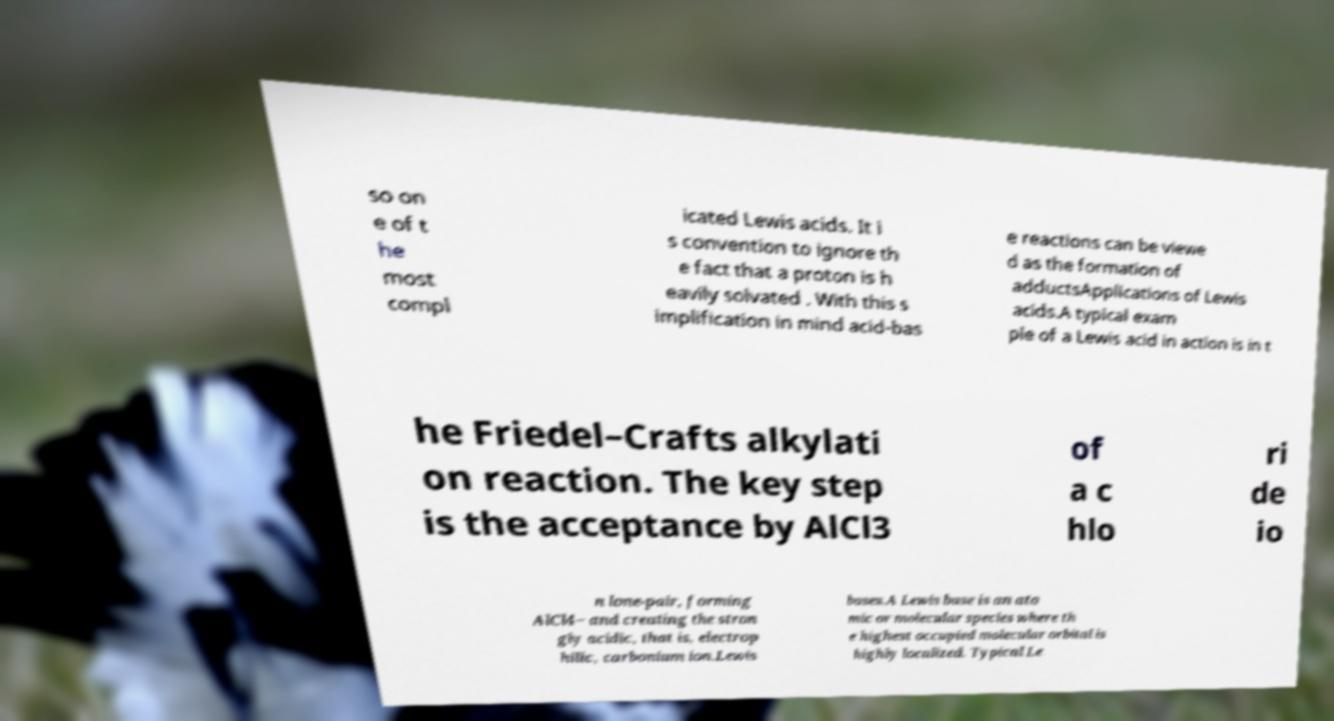There's text embedded in this image that I need extracted. Can you transcribe it verbatim? so on e of t he most compl icated Lewis acids. It i s convention to ignore th e fact that a proton is h eavily solvated . With this s implification in mind acid-bas e reactions can be viewe d as the formation of adductsApplications of Lewis acids.A typical exam ple of a Lewis acid in action is in t he Friedel–Crafts alkylati on reaction. The key step is the acceptance by AlCl3 of a c hlo ri de io n lone-pair, forming AlCl4− and creating the stron gly acidic, that is, electrop hilic, carbonium ion.Lewis bases.A Lewis base is an ato mic or molecular species where th e highest occupied molecular orbital is highly localized. Typical Le 